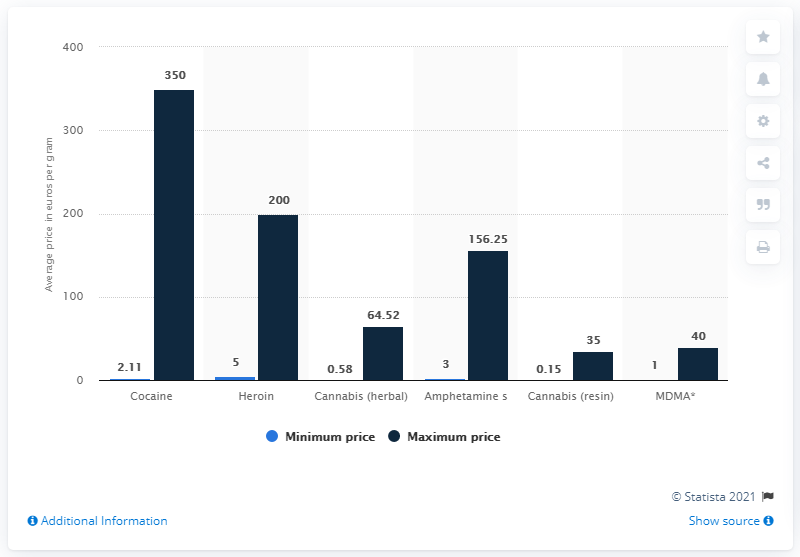Can you describe the trends shown in this chart for drug prices in Sweden? The chart presents a comparison of the minimum and maximum reported average prices per gram for various illicit drugs in Sweden. Cocaine stands out with the highest maximum average price, followed by heroin and amphetamines. The trend indicates that cocaine is significantly more expensive than the others, which could be due to its higher demand and the risks associated with its trafficking. 